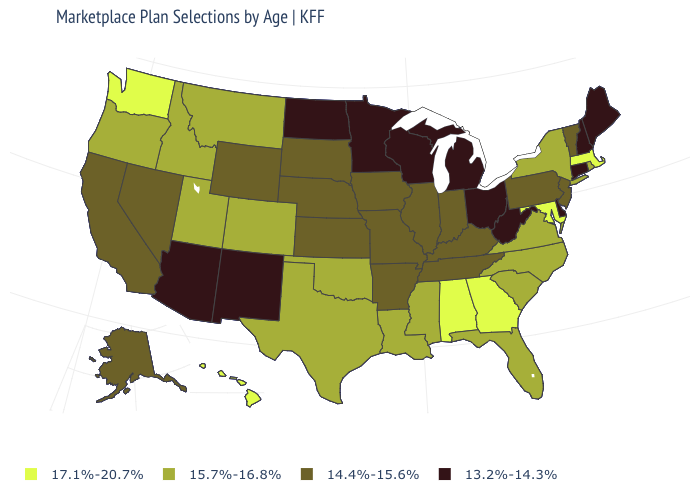What is the value of Ohio?
Keep it brief. 13.2%-14.3%. Name the states that have a value in the range 13.2%-14.3%?
Quick response, please. Arizona, Connecticut, Delaware, Maine, Michigan, Minnesota, New Hampshire, New Mexico, North Dakota, Ohio, West Virginia, Wisconsin. What is the value of New York?
Give a very brief answer. 15.7%-16.8%. What is the value of Idaho?
Give a very brief answer. 15.7%-16.8%. Name the states that have a value in the range 13.2%-14.3%?
Write a very short answer. Arizona, Connecticut, Delaware, Maine, Michigan, Minnesota, New Hampshire, New Mexico, North Dakota, Ohio, West Virginia, Wisconsin. Does the first symbol in the legend represent the smallest category?
Write a very short answer. No. Does Utah have the highest value in the West?
Give a very brief answer. No. What is the value of New Mexico?
Answer briefly. 13.2%-14.3%. What is the lowest value in the USA?
Keep it brief. 13.2%-14.3%. What is the value of Colorado?
Quick response, please. 15.7%-16.8%. Does Maryland have the highest value in the USA?
Concise answer only. Yes. What is the lowest value in the USA?
Give a very brief answer. 13.2%-14.3%. What is the value of Nevada?
Short answer required. 14.4%-15.6%. What is the value of West Virginia?
Answer briefly. 13.2%-14.3%. 